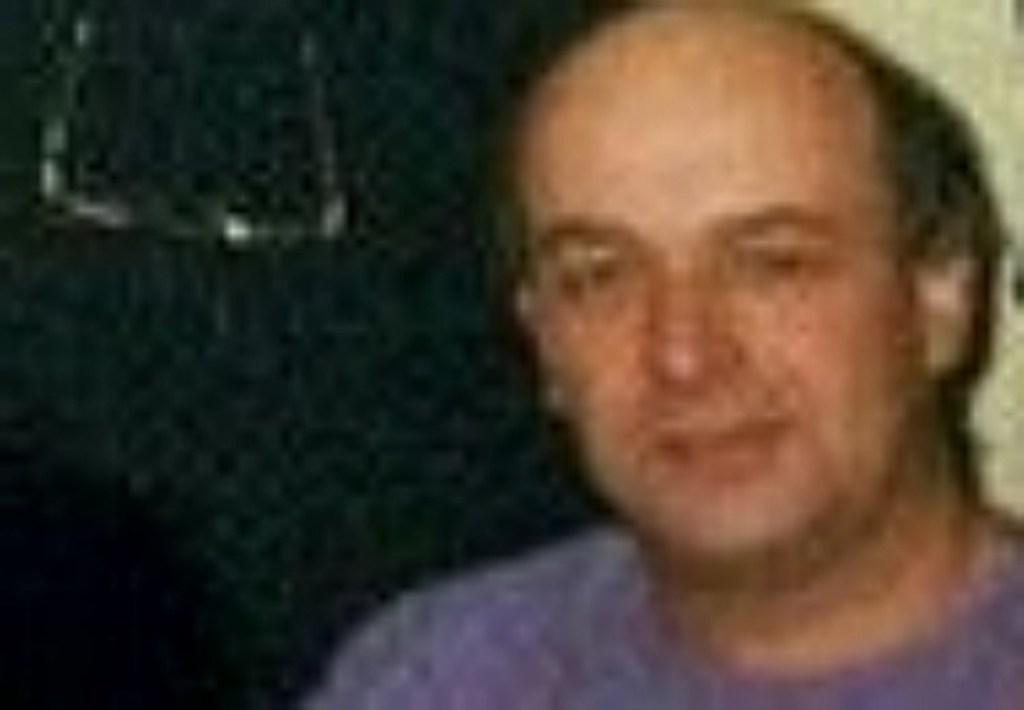What is the main subject of the image? There is a person in the image. Can you describe the background of the image? The background of the image is blurred. What type of interest can be seen growing in the image? There is no interest present in the image; it features a person with a blurred background. What kind of root is visible in the image? There is no root visible in the image; it features a person with a blurred background. 